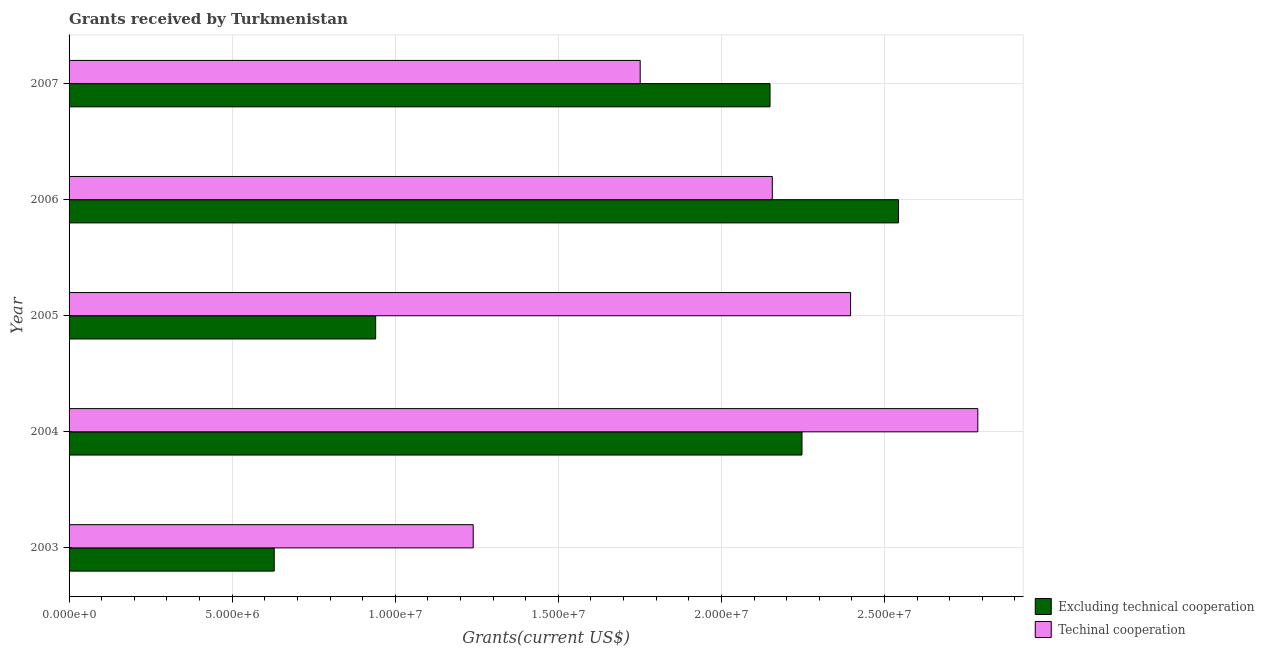How many different coloured bars are there?
Make the answer very short. 2. How many groups of bars are there?
Offer a very short reply. 5. Are the number of bars on each tick of the Y-axis equal?
Give a very brief answer. Yes. How many bars are there on the 3rd tick from the top?
Ensure brevity in your answer.  2. What is the label of the 5th group of bars from the top?
Your response must be concise. 2003. What is the amount of grants received(excluding technical cooperation) in 2006?
Your answer should be very brief. 2.54e+07. Across all years, what is the maximum amount of grants received(excluding technical cooperation)?
Offer a terse response. 2.54e+07. Across all years, what is the minimum amount of grants received(including technical cooperation)?
Your answer should be very brief. 1.24e+07. In which year was the amount of grants received(excluding technical cooperation) maximum?
Provide a succinct answer. 2006. In which year was the amount of grants received(excluding technical cooperation) minimum?
Your answer should be compact. 2003. What is the total amount of grants received(including technical cooperation) in the graph?
Provide a short and direct response. 1.03e+08. What is the difference between the amount of grants received(excluding technical cooperation) in 2004 and that in 2007?
Your answer should be compact. 9.80e+05. What is the difference between the amount of grants received(excluding technical cooperation) in 2005 and the amount of grants received(including technical cooperation) in 2006?
Ensure brevity in your answer.  -1.22e+07. What is the average amount of grants received(including technical cooperation) per year?
Your response must be concise. 2.07e+07. In the year 2003, what is the difference between the amount of grants received(including technical cooperation) and amount of grants received(excluding technical cooperation)?
Your answer should be compact. 6.10e+06. What is the ratio of the amount of grants received(including technical cooperation) in 2003 to that in 2006?
Offer a terse response. 0.57. Is the difference between the amount of grants received(excluding technical cooperation) in 2004 and 2007 greater than the difference between the amount of grants received(including technical cooperation) in 2004 and 2007?
Keep it short and to the point. No. What is the difference between the highest and the second highest amount of grants received(including technical cooperation)?
Give a very brief answer. 3.90e+06. What is the difference between the highest and the lowest amount of grants received(including technical cooperation)?
Give a very brief answer. 1.55e+07. Is the sum of the amount of grants received(including technical cooperation) in 2006 and 2007 greater than the maximum amount of grants received(excluding technical cooperation) across all years?
Keep it short and to the point. Yes. What does the 2nd bar from the top in 2007 represents?
Give a very brief answer. Excluding technical cooperation. What does the 1st bar from the bottom in 2005 represents?
Your answer should be very brief. Excluding technical cooperation. How many bars are there?
Give a very brief answer. 10. What is the difference between two consecutive major ticks on the X-axis?
Provide a succinct answer. 5.00e+06. Are the values on the major ticks of X-axis written in scientific E-notation?
Your answer should be compact. Yes. Does the graph contain any zero values?
Keep it short and to the point. No. Does the graph contain grids?
Your answer should be compact. Yes. What is the title of the graph?
Make the answer very short. Grants received by Turkmenistan. Does "Rural Population" appear as one of the legend labels in the graph?
Your response must be concise. No. What is the label or title of the X-axis?
Offer a terse response. Grants(current US$). What is the label or title of the Y-axis?
Your response must be concise. Year. What is the Grants(current US$) of Excluding technical cooperation in 2003?
Make the answer very short. 6.29e+06. What is the Grants(current US$) of Techinal cooperation in 2003?
Give a very brief answer. 1.24e+07. What is the Grants(current US$) of Excluding technical cooperation in 2004?
Make the answer very short. 2.25e+07. What is the Grants(current US$) in Techinal cooperation in 2004?
Give a very brief answer. 2.79e+07. What is the Grants(current US$) of Excluding technical cooperation in 2005?
Offer a terse response. 9.40e+06. What is the Grants(current US$) in Techinal cooperation in 2005?
Your answer should be compact. 2.40e+07. What is the Grants(current US$) in Excluding technical cooperation in 2006?
Provide a short and direct response. 2.54e+07. What is the Grants(current US$) in Techinal cooperation in 2006?
Provide a short and direct response. 2.16e+07. What is the Grants(current US$) in Excluding technical cooperation in 2007?
Keep it short and to the point. 2.15e+07. What is the Grants(current US$) in Techinal cooperation in 2007?
Ensure brevity in your answer.  1.75e+07. Across all years, what is the maximum Grants(current US$) of Excluding technical cooperation?
Your answer should be very brief. 2.54e+07. Across all years, what is the maximum Grants(current US$) of Techinal cooperation?
Keep it short and to the point. 2.79e+07. Across all years, what is the minimum Grants(current US$) of Excluding technical cooperation?
Your answer should be compact. 6.29e+06. Across all years, what is the minimum Grants(current US$) in Techinal cooperation?
Provide a short and direct response. 1.24e+07. What is the total Grants(current US$) in Excluding technical cooperation in the graph?
Your answer should be compact. 8.51e+07. What is the total Grants(current US$) of Techinal cooperation in the graph?
Your response must be concise. 1.03e+08. What is the difference between the Grants(current US$) of Excluding technical cooperation in 2003 and that in 2004?
Provide a short and direct response. -1.62e+07. What is the difference between the Grants(current US$) in Techinal cooperation in 2003 and that in 2004?
Keep it short and to the point. -1.55e+07. What is the difference between the Grants(current US$) in Excluding technical cooperation in 2003 and that in 2005?
Give a very brief answer. -3.11e+06. What is the difference between the Grants(current US$) in Techinal cooperation in 2003 and that in 2005?
Offer a terse response. -1.16e+07. What is the difference between the Grants(current US$) in Excluding technical cooperation in 2003 and that in 2006?
Keep it short and to the point. -1.91e+07. What is the difference between the Grants(current US$) of Techinal cooperation in 2003 and that in 2006?
Offer a very short reply. -9.17e+06. What is the difference between the Grants(current US$) of Excluding technical cooperation in 2003 and that in 2007?
Offer a very short reply. -1.52e+07. What is the difference between the Grants(current US$) of Techinal cooperation in 2003 and that in 2007?
Your response must be concise. -5.12e+06. What is the difference between the Grants(current US$) of Excluding technical cooperation in 2004 and that in 2005?
Make the answer very short. 1.31e+07. What is the difference between the Grants(current US$) of Techinal cooperation in 2004 and that in 2005?
Your answer should be compact. 3.90e+06. What is the difference between the Grants(current US$) in Excluding technical cooperation in 2004 and that in 2006?
Offer a very short reply. -2.96e+06. What is the difference between the Grants(current US$) of Techinal cooperation in 2004 and that in 2006?
Offer a very short reply. 6.30e+06. What is the difference between the Grants(current US$) of Excluding technical cooperation in 2004 and that in 2007?
Your answer should be compact. 9.80e+05. What is the difference between the Grants(current US$) of Techinal cooperation in 2004 and that in 2007?
Provide a short and direct response. 1.04e+07. What is the difference between the Grants(current US$) in Excluding technical cooperation in 2005 and that in 2006?
Give a very brief answer. -1.60e+07. What is the difference between the Grants(current US$) in Techinal cooperation in 2005 and that in 2006?
Your response must be concise. 2.40e+06. What is the difference between the Grants(current US$) in Excluding technical cooperation in 2005 and that in 2007?
Keep it short and to the point. -1.21e+07. What is the difference between the Grants(current US$) in Techinal cooperation in 2005 and that in 2007?
Your response must be concise. 6.45e+06. What is the difference between the Grants(current US$) in Excluding technical cooperation in 2006 and that in 2007?
Ensure brevity in your answer.  3.94e+06. What is the difference between the Grants(current US$) of Techinal cooperation in 2006 and that in 2007?
Provide a succinct answer. 4.05e+06. What is the difference between the Grants(current US$) of Excluding technical cooperation in 2003 and the Grants(current US$) of Techinal cooperation in 2004?
Ensure brevity in your answer.  -2.16e+07. What is the difference between the Grants(current US$) of Excluding technical cooperation in 2003 and the Grants(current US$) of Techinal cooperation in 2005?
Your answer should be compact. -1.77e+07. What is the difference between the Grants(current US$) in Excluding technical cooperation in 2003 and the Grants(current US$) in Techinal cooperation in 2006?
Ensure brevity in your answer.  -1.53e+07. What is the difference between the Grants(current US$) of Excluding technical cooperation in 2003 and the Grants(current US$) of Techinal cooperation in 2007?
Offer a very short reply. -1.12e+07. What is the difference between the Grants(current US$) in Excluding technical cooperation in 2004 and the Grants(current US$) in Techinal cooperation in 2005?
Ensure brevity in your answer.  -1.49e+06. What is the difference between the Grants(current US$) in Excluding technical cooperation in 2004 and the Grants(current US$) in Techinal cooperation in 2006?
Keep it short and to the point. 9.10e+05. What is the difference between the Grants(current US$) of Excluding technical cooperation in 2004 and the Grants(current US$) of Techinal cooperation in 2007?
Offer a terse response. 4.96e+06. What is the difference between the Grants(current US$) in Excluding technical cooperation in 2005 and the Grants(current US$) in Techinal cooperation in 2006?
Provide a succinct answer. -1.22e+07. What is the difference between the Grants(current US$) in Excluding technical cooperation in 2005 and the Grants(current US$) in Techinal cooperation in 2007?
Your response must be concise. -8.11e+06. What is the difference between the Grants(current US$) of Excluding technical cooperation in 2006 and the Grants(current US$) of Techinal cooperation in 2007?
Provide a short and direct response. 7.92e+06. What is the average Grants(current US$) in Excluding technical cooperation per year?
Offer a terse response. 1.70e+07. What is the average Grants(current US$) in Techinal cooperation per year?
Make the answer very short. 2.07e+07. In the year 2003, what is the difference between the Grants(current US$) of Excluding technical cooperation and Grants(current US$) of Techinal cooperation?
Provide a short and direct response. -6.10e+06. In the year 2004, what is the difference between the Grants(current US$) of Excluding technical cooperation and Grants(current US$) of Techinal cooperation?
Provide a succinct answer. -5.39e+06. In the year 2005, what is the difference between the Grants(current US$) in Excluding technical cooperation and Grants(current US$) in Techinal cooperation?
Provide a succinct answer. -1.46e+07. In the year 2006, what is the difference between the Grants(current US$) of Excluding technical cooperation and Grants(current US$) of Techinal cooperation?
Keep it short and to the point. 3.87e+06. In the year 2007, what is the difference between the Grants(current US$) of Excluding technical cooperation and Grants(current US$) of Techinal cooperation?
Offer a very short reply. 3.98e+06. What is the ratio of the Grants(current US$) of Excluding technical cooperation in 2003 to that in 2004?
Ensure brevity in your answer.  0.28. What is the ratio of the Grants(current US$) in Techinal cooperation in 2003 to that in 2004?
Give a very brief answer. 0.44. What is the ratio of the Grants(current US$) of Excluding technical cooperation in 2003 to that in 2005?
Ensure brevity in your answer.  0.67. What is the ratio of the Grants(current US$) in Techinal cooperation in 2003 to that in 2005?
Provide a short and direct response. 0.52. What is the ratio of the Grants(current US$) in Excluding technical cooperation in 2003 to that in 2006?
Provide a short and direct response. 0.25. What is the ratio of the Grants(current US$) in Techinal cooperation in 2003 to that in 2006?
Ensure brevity in your answer.  0.57. What is the ratio of the Grants(current US$) in Excluding technical cooperation in 2003 to that in 2007?
Ensure brevity in your answer.  0.29. What is the ratio of the Grants(current US$) in Techinal cooperation in 2003 to that in 2007?
Make the answer very short. 0.71. What is the ratio of the Grants(current US$) of Excluding technical cooperation in 2004 to that in 2005?
Your response must be concise. 2.39. What is the ratio of the Grants(current US$) of Techinal cooperation in 2004 to that in 2005?
Provide a succinct answer. 1.16. What is the ratio of the Grants(current US$) in Excluding technical cooperation in 2004 to that in 2006?
Provide a succinct answer. 0.88. What is the ratio of the Grants(current US$) in Techinal cooperation in 2004 to that in 2006?
Offer a very short reply. 1.29. What is the ratio of the Grants(current US$) of Excluding technical cooperation in 2004 to that in 2007?
Provide a short and direct response. 1.05. What is the ratio of the Grants(current US$) of Techinal cooperation in 2004 to that in 2007?
Provide a short and direct response. 1.59. What is the ratio of the Grants(current US$) in Excluding technical cooperation in 2005 to that in 2006?
Offer a very short reply. 0.37. What is the ratio of the Grants(current US$) in Techinal cooperation in 2005 to that in 2006?
Keep it short and to the point. 1.11. What is the ratio of the Grants(current US$) of Excluding technical cooperation in 2005 to that in 2007?
Your answer should be compact. 0.44. What is the ratio of the Grants(current US$) of Techinal cooperation in 2005 to that in 2007?
Your response must be concise. 1.37. What is the ratio of the Grants(current US$) in Excluding technical cooperation in 2006 to that in 2007?
Keep it short and to the point. 1.18. What is the ratio of the Grants(current US$) in Techinal cooperation in 2006 to that in 2007?
Provide a succinct answer. 1.23. What is the difference between the highest and the second highest Grants(current US$) of Excluding technical cooperation?
Make the answer very short. 2.96e+06. What is the difference between the highest and the second highest Grants(current US$) in Techinal cooperation?
Your answer should be very brief. 3.90e+06. What is the difference between the highest and the lowest Grants(current US$) of Excluding technical cooperation?
Ensure brevity in your answer.  1.91e+07. What is the difference between the highest and the lowest Grants(current US$) in Techinal cooperation?
Make the answer very short. 1.55e+07. 